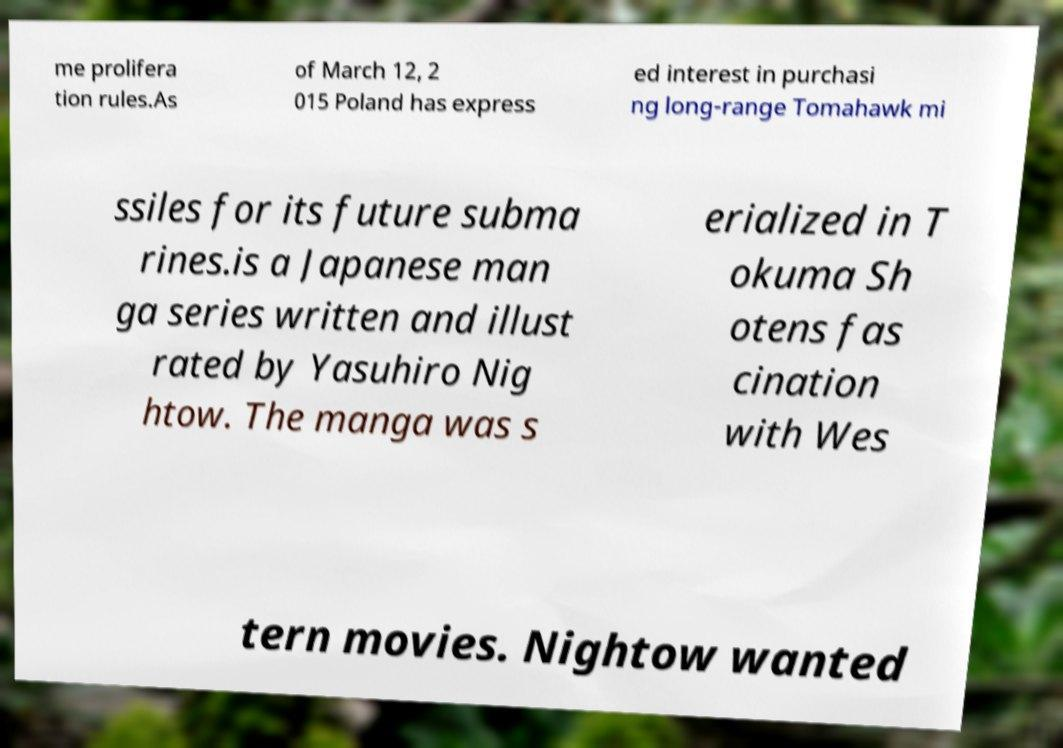What messages or text are displayed in this image? I need them in a readable, typed format. me prolifera tion rules.As of March 12, 2 015 Poland has express ed interest in purchasi ng long-range Tomahawk mi ssiles for its future subma rines.is a Japanese man ga series written and illust rated by Yasuhiro Nig htow. The manga was s erialized in T okuma Sh otens fas cination with Wes tern movies. Nightow wanted 